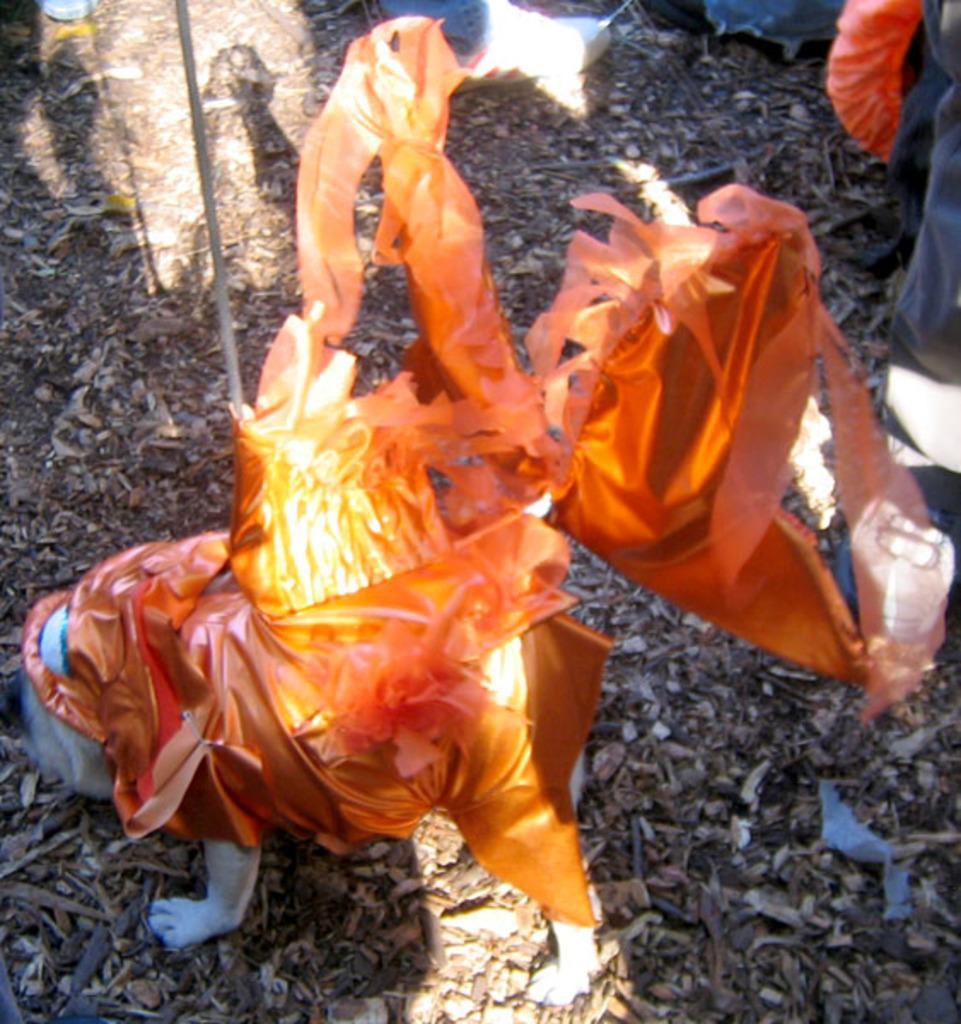Could you give a brief overview of what you see in this image? There is a dog wearing a orange color dress. Near to the dog there is a stick. And we can see some legs of the persons. On the ground there are dried leaves. 